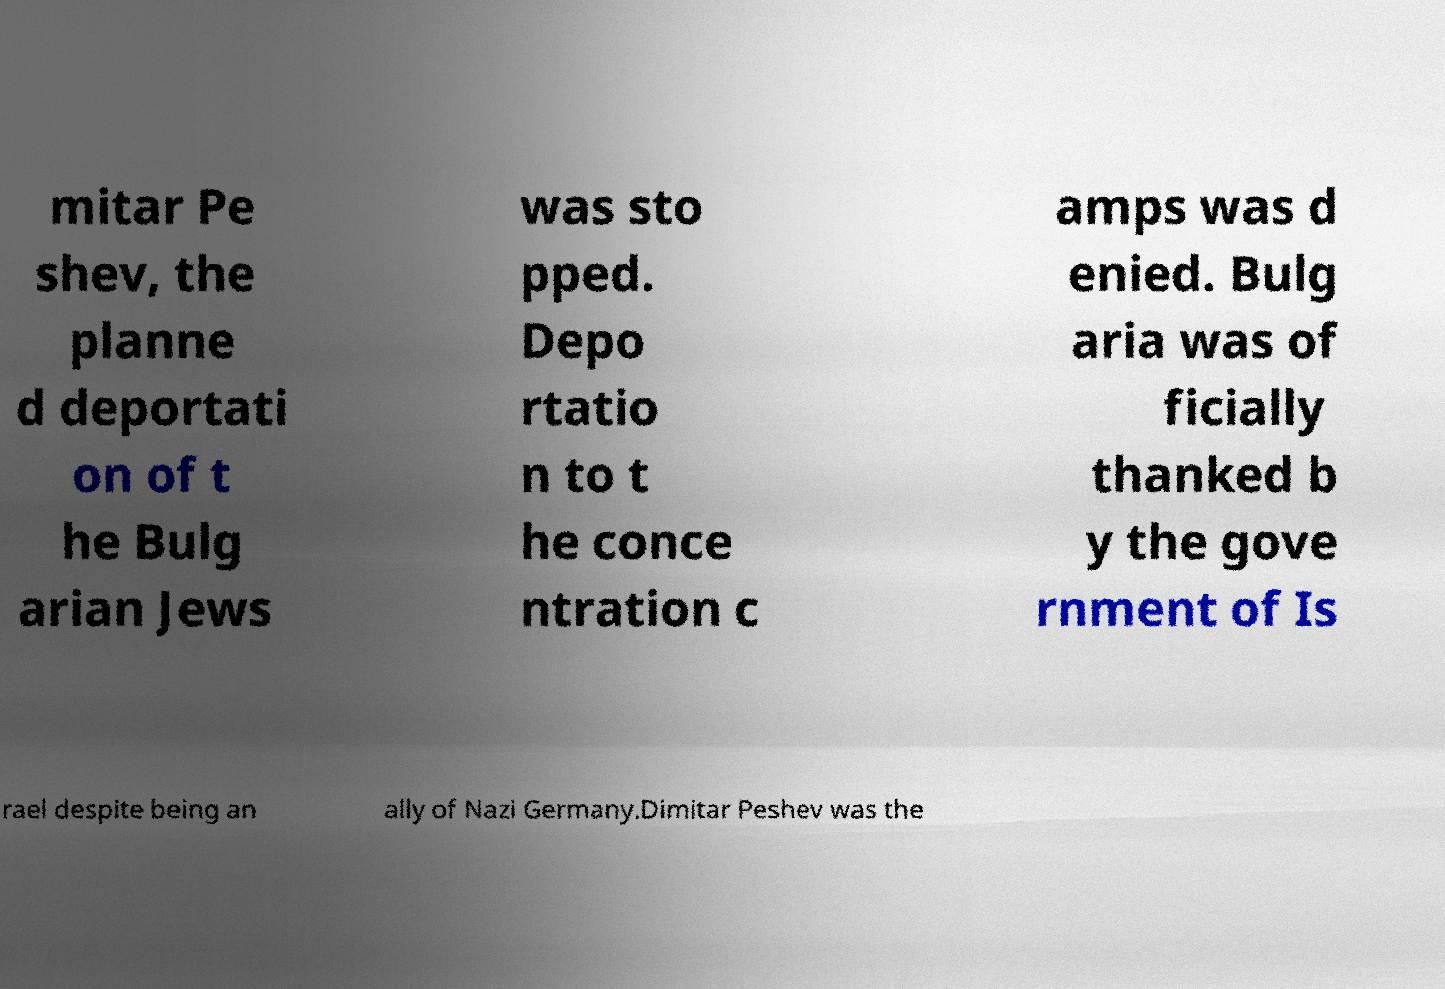Can you accurately transcribe the text from the provided image for me? mitar Pe shev, the planne d deportati on of t he Bulg arian Jews was sto pped. Depo rtatio n to t he conce ntration c amps was d enied. Bulg aria was of ficially thanked b y the gove rnment of Is rael despite being an ally of Nazi Germany.Dimitar Peshev was the 